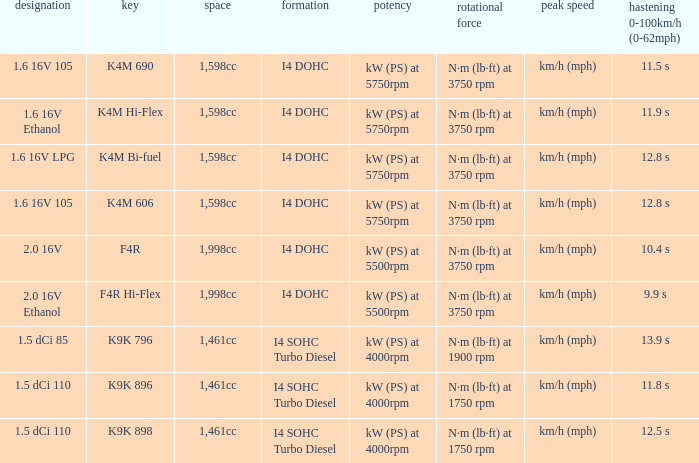Give me the full table as a dictionary. {'header': ['designation', 'key', 'space', 'formation', 'potency', 'rotational force', 'peak speed', 'hastening 0-100km/h (0-62mph)'], 'rows': [['1.6 16V 105', 'K4M 690', '1,598cc', 'I4 DOHC', 'kW (PS) at 5750rpm', 'N·m (lb·ft) at 3750 rpm', 'km/h (mph)', '11.5 s'], ['1.6 16V Ethanol', 'K4M Hi-Flex', '1,598cc', 'I4 DOHC', 'kW (PS) at 5750rpm', 'N·m (lb·ft) at 3750 rpm', 'km/h (mph)', '11.9 s'], ['1.6 16V LPG', 'K4M Bi-fuel', '1,598cc', 'I4 DOHC', 'kW (PS) at 5750rpm', 'N·m (lb·ft) at 3750 rpm', 'km/h (mph)', '12.8 s'], ['1.6 16V 105', 'K4M 606', '1,598cc', 'I4 DOHC', 'kW (PS) at 5750rpm', 'N·m (lb·ft) at 3750 rpm', 'km/h (mph)', '12.8 s'], ['2.0 16V', 'F4R', '1,998cc', 'I4 DOHC', 'kW (PS) at 5500rpm', 'N·m (lb·ft) at 3750 rpm', 'km/h (mph)', '10.4 s'], ['2.0 16V Ethanol', 'F4R Hi-Flex', '1,998cc', 'I4 DOHC', 'kW (PS) at 5500rpm', 'N·m (lb·ft) at 3750 rpm', 'km/h (mph)', '9.9 s'], ['1.5 dCi 85', 'K9K 796', '1,461cc', 'I4 SOHC Turbo Diesel', 'kW (PS) at 4000rpm', 'N·m (lb·ft) at 1900 rpm', 'km/h (mph)', '13.9 s'], ['1.5 dCi 110', 'K9K 896', '1,461cc', 'I4 SOHC Turbo Diesel', 'kW (PS) at 4000rpm', 'N·m (lb·ft) at 1750 rpm', 'km/h (mph)', '11.8 s'], ['1.5 dCi 110', 'K9K 898', '1,461cc', 'I4 SOHC Turbo Diesel', 'kW (PS) at 4000rpm', 'N·m (lb·ft) at 1750 rpm', 'km/h (mph)', '12.5 s']]} What is the capacity of code f4r? 1,998cc. 